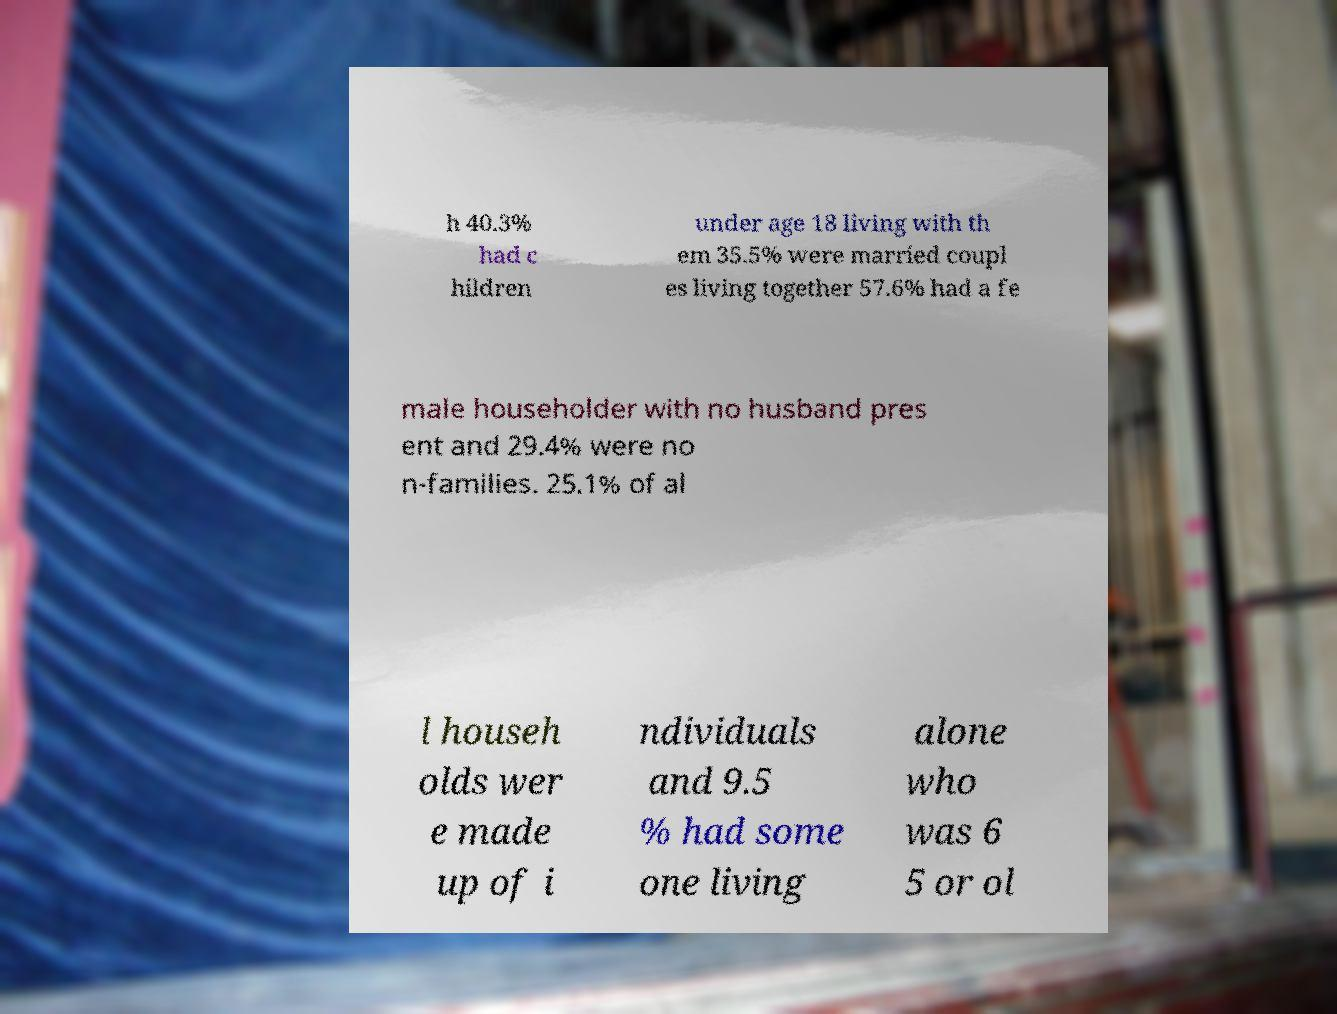Please read and relay the text visible in this image. What does it say? h 40.3% had c hildren under age 18 living with th em 35.5% were married coupl es living together 57.6% had a fe male householder with no husband pres ent and 29.4% were no n-families. 25.1% of al l househ olds wer e made up of i ndividuals and 9.5 % had some one living alone who was 6 5 or ol 